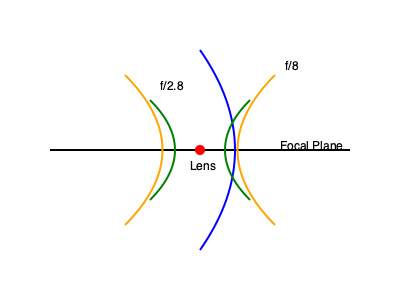In the diagram above, which aperture setting would result in a shallower depth of field when filming a subject at the focal plane? To understand the depth of field in relation to aperture, let's break down the concept:

1. Depth of field refers to the range of distance in which objects appear acceptably sharp in an image.

2. Aperture, represented by f-stops (like f/2.8 and f/8 in the diagram), controls the amount of light entering the lens and affects the depth of field.

3. A larger aperture (smaller f-number) results in a shallower depth of field. Conversely, a smaller aperture (larger f-number) increases the depth of field.

4. In the diagram:
   - The green curves represent the f/2.8 aperture setting
   - The orange curves represent the f/8 aperture setting

5. Notice that the f/2.8 curves are closer together, indicating a narrower range of focus and thus a shallower depth of field.

6. The f/8 curves are farther apart, showing a wider range of focus and a deeper depth of field.

Therefore, the f/2.8 aperture setting would result in a shallower depth of field when filming a subject at the focal plane.
Answer: f/2.8 